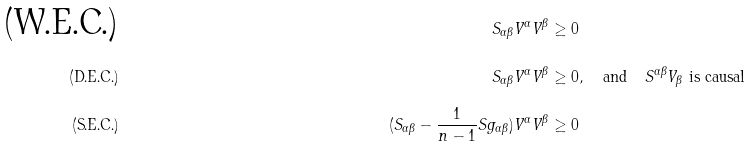Convert formula to latex. <formula><loc_0><loc_0><loc_500><loc_500>\text {(W.E.C.)} & & S _ { \alpha \beta } V ^ { \alpha } V ^ { \beta } & \geq 0 \\ \text {(D.E.C.)} & & S _ { \alpha \beta } V ^ { \alpha } V ^ { \beta } & \geq 0 , \quad \text {and} \quad S ^ { \alpha \beta } V _ { \beta } \text { is causal } \\ \text {(S.E.C.)} & & ( S _ { \alpha \beta } - \frac { 1 } { n - 1 } S g _ { \alpha \beta } ) V ^ { \alpha } V ^ { \beta } & \geq 0</formula> 